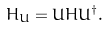Convert formula to latex. <formula><loc_0><loc_0><loc_500><loc_500>H _ { U } = U H U ^ { \dagger } .</formula> 